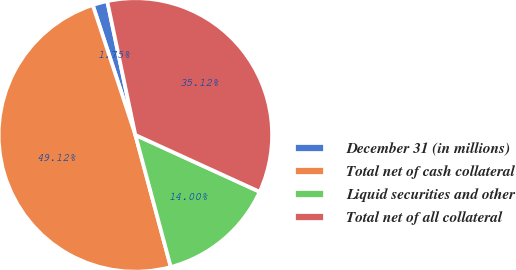Convert chart to OTSL. <chart><loc_0><loc_0><loc_500><loc_500><pie_chart><fcel>December 31 (in millions)<fcel>Total net of cash collateral<fcel>Liquid securities and other<fcel>Total net of all collateral<nl><fcel>1.75%<fcel>49.12%<fcel>14.0%<fcel>35.12%<nl></chart> 